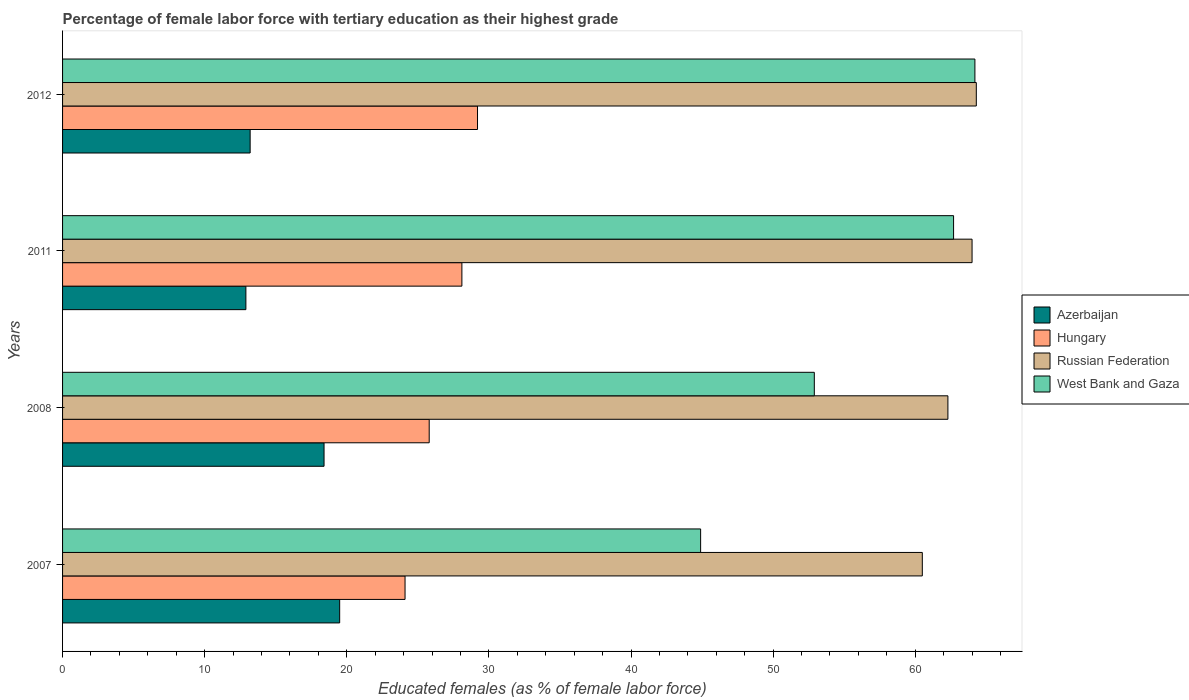Are the number of bars per tick equal to the number of legend labels?
Your response must be concise. Yes. Are the number of bars on each tick of the Y-axis equal?
Your response must be concise. Yes. What is the percentage of female labor force with tertiary education in West Bank and Gaza in 2012?
Keep it short and to the point. 64.2. Across all years, what is the maximum percentage of female labor force with tertiary education in Russian Federation?
Keep it short and to the point. 64.3. Across all years, what is the minimum percentage of female labor force with tertiary education in Hungary?
Give a very brief answer. 24.1. In which year was the percentage of female labor force with tertiary education in West Bank and Gaza minimum?
Ensure brevity in your answer.  2007. What is the total percentage of female labor force with tertiary education in West Bank and Gaza in the graph?
Your response must be concise. 224.7. What is the difference between the percentage of female labor force with tertiary education in Hungary in 2007 and that in 2008?
Offer a very short reply. -1.7. What is the difference between the percentage of female labor force with tertiary education in Hungary in 2007 and the percentage of female labor force with tertiary education in West Bank and Gaza in 2012?
Make the answer very short. -40.1. What is the average percentage of female labor force with tertiary education in West Bank and Gaza per year?
Give a very brief answer. 56.18. In the year 2011, what is the difference between the percentage of female labor force with tertiary education in Hungary and percentage of female labor force with tertiary education in Azerbaijan?
Your response must be concise. 15.2. What is the ratio of the percentage of female labor force with tertiary education in West Bank and Gaza in 2007 to that in 2012?
Provide a succinct answer. 0.7. What is the difference between the highest and the second highest percentage of female labor force with tertiary education in West Bank and Gaza?
Your answer should be very brief. 1.5. What is the difference between the highest and the lowest percentage of female labor force with tertiary education in Hungary?
Make the answer very short. 5.1. Is it the case that in every year, the sum of the percentage of female labor force with tertiary education in West Bank and Gaza and percentage of female labor force with tertiary education in Russian Federation is greater than the sum of percentage of female labor force with tertiary education in Azerbaijan and percentage of female labor force with tertiary education in Hungary?
Your answer should be compact. Yes. What does the 1st bar from the top in 2008 represents?
Your response must be concise. West Bank and Gaza. What does the 4th bar from the bottom in 2011 represents?
Offer a very short reply. West Bank and Gaza. Are all the bars in the graph horizontal?
Your answer should be very brief. Yes. Are the values on the major ticks of X-axis written in scientific E-notation?
Provide a succinct answer. No. Does the graph contain any zero values?
Offer a terse response. No. Where does the legend appear in the graph?
Your answer should be compact. Center right. What is the title of the graph?
Your response must be concise. Percentage of female labor force with tertiary education as their highest grade. What is the label or title of the X-axis?
Offer a terse response. Educated females (as % of female labor force). What is the Educated females (as % of female labor force) in Hungary in 2007?
Your response must be concise. 24.1. What is the Educated females (as % of female labor force) in Russian Federation in 2007?
Provide a short and direct response. 60.5. What is the Educated females (as % of female labor force) of West Bank and Gaza in 2007?
Offer a very short reply. 44.9. What is the Educated females (as % of female labor force) in Azerbaijan in 2008?
Offer a terse response. 18.4. What is the Educated females (as % of female labor force) in Hungary in 2008?
Your answer should be compact. 25.8. What is the Educated females (as % of female labor force) in Russian Federation in 2008?
Make the answer very short. 62.3. What is the Educated females (as % of female labor force) of West Bank and Gaza in 2008?
Provide a succinct answer. 52.9. What is the Educated females (as % of female labor force) of Azerbaijan in 2011?
Offer a terse response. 12.9. What is the Educated females (as % of female labor force) in Hungary in 2011?
Offer a very short reply. 28.1. What is the Educated females (as % of female labor force) of West Bank and Gaza in 2011?
Your answer should be very brief. 62.7. What is the Educated females (as % of female labor force) of Azerbaijan in 2012?
Your response must be concise. 13.2. What is the Educated females (as % of female labor force) in Hungary in 2012?
Your response must be concise. 29.2. What is the Educated females (as % of female labor force) of Russian Federation in 2012?
Give a very brief answer. 64.3. What is the Educated females (as % of female labor force) of West Bank and Gaza in 2012?
Keep it short and to the point. 64.2. Across all years, what is the maximum Educated females (as % of female labor force) in Azerbaijan?
Your response must be concise. 19.5. Across all years, what is the maximum Educated females (as % of female labor force) of Hungary?
Your answer should be very brief. 29.2. Across all years, what is the maximum Educated females (as % of female labor force) of Russian Federation?
Offer a very short reply. 64.3. Across all years, what is the maximum Educated females (as % of female labor force) in West Bank and Gaza?
Provide a short and direct response. 64.2. Across all years, what is the minimum Educated females (as % of female labor force) in Azerbaijan?
Ensure brevity in your answer.  12.9. Across all years, what is the minimum Educated females (as % of female labor force) in Hungary?
Your answer should be compact. 24.1. Across all years, what is the minimum Educated females (as % of female labor force) of Russian Federation?
Offer a terse response. 60.5. Across all years, what is the minimum Educated females (as % of female labor force) in West Bank and Gaza?
Offer a very short reply. 44.9. What is the total Educated females (as % of female labor force) of Azerbaijan in the graph?
Your response must be concise. 64. What is the total Educated females (as % of female labor force) of Hungary in the graph?
Your answer should be very brief. 107.2. What is the total Educated females (as % of female labor force) of Russian Federation in the graph?
Your answer should be compact. 251.1. What is the total Educated females (as % of female labor force) in West Bank and Gaza in the graph?
Your response must be concise. 224.7. What is the difference between the Educated females (as % of female labor force) in Hungary in 2007 and that in 2011?
Make the answer very short. -4. What is the difference between the Educated females (as % of female labor force) of West Bank and Gaza in 2007 and that in 2011?
Make the answer very short. -17.8. What is the difference between the Educated females (as % of female labor force) of Azerbaijan in 2007 and that in 2012?
Offer a very short reply. 6.3. What is the difference between the Educated females (as % of female labor force) of Hungary in 2007 and that in 2012?
Offer a very short reply. -5.1. What is the difference between the Educated females (as % of female labor force) in Russian Federation in 2007 and that in 2012?
Make the answer very short. -3.8. What is the difference between the Educated females (as % of female labor force) in West Bank and Gaza in 2007 and that in 2012?
Make the answer very short. -19.3. What is the difference between the Educated females (as % of female labor force) of Azerbaijan in 2008 and that in 2011?
Provide a short and direct response. 5.5. What is the difference between the Educated females (as % of female labor force) of Russian Federation in 2008 and that in 2011?
Make the answer very short. -1.7. What is the difference between the Educated females (as % of female labor force) of Azerbaijan in 2007 and the Educated females (as % of female labor force) of Russian Federation in 2008?
Offer a very short reply. -42.8. What is the difference between the Educated females (as % of female labor force) of Azerbaijan in 2007 and the Educated females (as % of female labor force) of West Bank and Gaza in 2008?
Ensure brevity in your answer.  -33.4. What is the difference between the Educated females (as % of female labor force) in Hungary in 2007 and the Educated females (as % of female labor force) in Russian Federation in 2008?
Make the answer very short. -38.2. What is the difference between the Educated females (as % of female labor force) in Hungary in 2007 and the Educated females (as % of female labor force) in West Bank and Gaza in 2008?
Offer a very short reply. -28.8. What is the difference between the Educated females (as % of female labor force) in Russian Federation in 2007 and the Educated females (as % of female labor force) in West Bank and Gaza in 2008?
Offer a terse response. 7.6. What is the difference between the Educated females (as % of female labor force) in Azerbaijan in 2007 and the Educated females (as % of female labor force) in Russian Federation in 2011?
Provide a short and direct response. -44.5. What is the difference between the Educated females (as % of female labor force) in Azerbaijan in 2007 and the Educated females (as % of female labor force) in West Bank and Gaza in 2011?
Provide a succinct answer. -43.2. What is the difference between the Educated females (as % of female labor force) of Hungary in 2007 and the Educated females (as % of female labor force) of Russian Federation in 2011?
Keep it short and to the point. -39.9. What is the difference between the Educated females (as % of female labor force) of Hungary in 2007 and the Educated females (as % of female labor force) of West Bank and Gaza in 2011?
Your answer should be compact. -38.6. What is the difference between the Educated females (as % of female labor force) of Azerbaijan in 2007 and the Educated females (as % of female labor force) of Hungary in 2012?
Ensure brevity in your answer.  -9.7. What is the difference between the Educated females (as % of female labor force) in Azerbaijan in 2007 and the Educated females (as % of female labor force) in Russian Federation in 2012?
Provide a succinct answer. -44.8. What is the difference between the Educated females (as % of female labor force) in Azerbaijan in 2007 and the Educated females (as % of female labor force) in West Bank and Gaza in 2012?
Provide a short and direct response. -44.7. What is the difference between the Educated females (as % of female labor force) in Hungary in 2007 and the Educated females (as % of female labor force) in Russian Federation in 2012?
Ensure brevity in your answer.  -40.2. What is the difference between the Educated females (as % of female labor force) of Hungary in 2007 and the Educated females (as % of female labor force) of West Bank and Gaza in 2012?
Offer a very short reply. -40.1. What is the difference between the Educated females (as % of female labor force) in Azerbaijan in 2008 and the Educated females (as % of female labor force) in Russian Federation in 2011?
Make the answer very short. -45.6. What is the difference between the Educated females (as % of female labor force) in Azerbaijan in 2008 and the Educated females (as % of female labor force) in West Bank and Gaza in 2011?
Offer a terse response. -44.3. What is the difference between the Educated females (as % of female labor force) in Hungary in 2008 and the Educated females (as % of female labor force) in Russian Federation in 2011?
Your answer should be very brief. -38.2. What is the difference between the Educated females (as % of female labor force) in Hungary in 2008 and the Educated females (as % of female labor force) in West Bank and Gaza in 2011?
Keep it short and to the point. -36.9. What is the difference between the Educated females (as % of female labor force) of Azerbaijan in 2008 and the Educated females (as % of female labor force) of Hungary in 2012?
Provide a short and direct response. -10.8. What is the difference between the Educated females (as % of female labor force) of Azerbaijan in 2008 and the Educated females (as % of female labor force) of Russian Federation in 2012?
Provide a short and direct response. -45.9. What is the difference between the Educated females (as % of female labor force) in Azerbaijan in 2008 and the Educated females (as % of female labor force) in West Bank and Gaza in 2012?
Offer a terse response. -45.8. What is the difference between the Educated females (as % of female labor force) of Hungary in 2008 and the Educated females (as % of female labor force) of Russian Federation in 2012?
Offer a very short reply. -38.5. What is the difference between the Educated females (as % of female labor force) in Hungary in 2008 and the Educated females (as % of female labor force) in West Bank and Gaza in 2012?
Make the answer very short. -38.4. What is the difference between the Educated females (as % of female labor force) of Russian Federation in 2008 and the Educated females (as % of female labor force) of West Bank and Gaza in 2012?
Your answer should be very brief. -1.9. What is the difference between the Educated females (as % of female labor force) in Azerbaijan in 2011 and the Educated females (as % of female labor force) in Hungary in 2012?
Your response must be concise. -16.3. What is the difference between the Educated females (as % of female labor force) of Azerbaijan in 2011 and the Educated females (as % of female labor force) of Russian Federation in 2012?
Keep it short and to the point. -51.4. What is the difference between the Educated females (as % of female labor force) in Azerbaijan in 2011 and the Educated females (as % of female labor force) in West Bank and Gaza in 2012?
Offer a terse response. -51.3. What is the difference between the Educated females (as % of female labor force) in Hungary in 2011 and the Educated females (as % of female labor force) in Russian Federation in 2012?
Give a very brief answer. -36.2. What is the difference between the Educated females (as % of female labor force) of Hungary in 2011 and the Educated females (as % of female labor force) of West Bank and Gaza in 2012?
Provide a succinct answer. -36.1. What is the average Educated females (as % of female labor force) of Azerbaijan per year?
Give a very brief answer. 16. What is the average Educated females (as % of female labor force) of Hungary per year?
Keep it short and to the point. 26.8. What is the average Educated females (as % of female labor force) of Russian Federation per year?
Provide a short and direct response. 62.77. What is the average Educated females (as % of female labor force) in West Bank and Gaza per year?
Give a very brief answer. 56.17. In the year 2007, what is the difference between the Educated females (as % of female labor force) of Azerbaijan and Educated females (as % of female labor force) of Hungary?
Provide a short and direct response. -4.6. In the year 2007, what is the difference between the Educated females (as % of female labor force) of Azerbaijan and Educated females (as % of female labor force) of Russian Federation?
Provide a succinct answer. -41. In the year 2007, what is the difference between the Educated females (as % of female labor force) of Azerbaijan and Educated females (as % of female labor force) of West Bank and Gaza?
Offer a very short reply. -25.4. In the year 2007, what is the difference between the Educated females (as % of female labor force) of Hungary and Educated females (as % of female labor force) of Russian Federation?
Your response must be concise. -36.4. In the year 2007, what is the difference between the Educated females (as % of female labor force) in Hungary and Educated females (as % of female labor force) in West Bank and Gaza?
Offer a very short reply. -20.8. In the year 2008, what is the difference between the Educated females (as % of female labor force) of Azerbaijan and Educated females (as % of female labor force) of Hungary?
Provide a short and direct response. -7.4. In the year 2008, what is the difference between the Educated females (as % of female labor force) of Azerbaijan and Educated females (as % of female labor force) of Russian Federation?
Give a very brief answer. -43.9. In the year 2008, what is the difference between the Educated females (as % of female labor force) in Azerbaijan and Educated females (as % of female labor force) in West Bank and Gaza?
Offer a very short reply. -34.5. In the year 2008, what is the difference between the Educated females (as % of female labor force) in Hungary and Educated females (as % of female labor force) in Russian Federation?
Your answer should be very brief. -36.5. In the year 2008, what is the difference between the Educated females (as % of female labor force) in Hungary and Educated females (as % of female labor force) in West Bank and Gaza?
Your response must be concise. -27.1. In the year 2008, what is the difference between the Educated females (as % of female labor force) in Russian Federation and Educated females (as % of female labor force) in West Bank and Gaza?
Your answer should be compact. 9.4. In the year 2011, what is the difference between the Educated females (as % of female labor force) of Azerbaijan and Educated females (as % of female labor force) of Hungary?
Offer a terse response. -15.2. In the year 2011, what is the difference between the Educated females (as % of female labor force) of Azerbaijan and Educated females (as % of female labor force) of Russian Federation?
Give a very brief answer. -51.1. In the year 2011, what is the difference between the Educated females (as % of female labor force) in Azerbaijan and Educated females (as % of female labor force) in West Bank and Gaza?
Give a very brief answer. -49.8. In the year 2011, what is the difference between the Educated females (as % of female labor force) in Hungary and Educated females (as % of female labor force) in Russian Federation?
Provide a succinct answer. -35.9. In the year 2011, what is the difference between the Educated females (as % of female labor force) of Hungary and Educated females (as % of female labor force) of West Bank and Gaza?
Offer a terse response. -34.6. In the year 2011, what is the difference between the Educated females (as % of female labor force) in Russian Federation and Educated females (as % of female labor force) in West Bank and Gaza?
Provide a succinct answer. 1.3. In the year 2012, what is the difference between the Educated females (as % of female labor force) of Azerbaijan and Educated females (as % of female labor force) of Russian Federation?
Ensure brevity in your answer.  -51.1. In the year 2012, what is the difference between the Educated females (as % of female labor force) of Azerbaijan and Educated females (as % of female labor force) of West Bank and Gaza?
Provide a short and direct response. -51. In the year 2012, what is the difference between the Educated females (as % of female labor force) of Hungary and Educated females (as % of female labor force) of Russian Federation?
Provide a short and direct response. -35.1. In the year 2012, what is the difference between the Educated females (as % of female labor force) in Hungary and Educated females (as % of female labor force) in West Bank and Gaza?
Your answer should be compact. -35. What is the ratio of the Educated females (as % of female labor force) in Azerbaijan in 2007 to that in 2008?
Ensure brevity in your answer.  1.06. What is the ratio of the Educated females (as % of female labor force) of Hungary in 2007 to that in 2008?
Give a very brief answer. 0.93. What is the ratio of the Educated females (as % of female labor force) of Russian Federation in 2007 to that in 2008?
Give a very brief answer. 0.97. What is the ratio of the Educated females (as % of female labor force) in West Bank and Gaza in 2007 to that in 2008?
Provide a succinct answer. 0.85. What is the ratio of the Educated females (as % of female labor force) of Azerbaijan in 2007 to that in 2011?
Provide a succinct answer. 1.51. What is the ratio of the Educated females (as % of female labor force) in Hungary in 2007 to that in 2011?
Provide a succinct answer. 0.86. What is the ratio of the Educated females (as % of female labor force) in Russian Federation in 2007 to that in 2011?
Your response must be concise. 0.95. What is the ratio of the Educated females (as % of female labor force) in West Bank and Gaza in 2007 to that in 2011?
Provide a succinct answer. 0.72. What is the ratio of the Educated females (as % of female labor force) of Azerbaijan in 2007 to that in 2012?
Keep it short and to the point. 1.48. What is the ratio of the Educated females (as % of female labor force) in Hungary in 2007 to that in 2012?
Your answer should be very brief. 0.83. What is the ratio of the Educated females (as % of female labor force) in Russian Federation in 2007 to that in 2012?
Provide a succinct answer. 0.94. What is the ratio of the Educated females (as % of female labor force) of West Bank and Gaza in 2007 to that in 2012?
Your response must be concise. 0.7. What is the ratio of the Educated females (as % of female labor force) of Azerbaijan in 2008 to that in 2011?
Provide a succinct answer. 1.43. What is the ratio of the Educated females (as % of female labor force) of Hungary in 2008 to that in 2011?
Provide a short and direct response. 0.92. What is the ratio of the Educated females (as % of female labor force) in Russian Federation in 2008 to that in 2011?
Ensure brevity in your answer.  0.97. What is the ratio of the Educated females (as % of female labor force) of West Bank and Gaza in 2008 to that in 2011?
Offer a terse response. 0.84. What is the ratio of the Educated females (as % of female labor force) of Azerbaijan in 2008 to that in 2012?
Offer a terse response. 1.39. What is the ratio of the Educated females (as % of female labor force) of Hungary in 2008 to that in 2012?
Offer a terse response. 0.88. What is the ratio of the Educated females (as % of female labor force) of Russian Federation in 2008 to that in 2012?
Make the answer very short. 0.97. What is the ratio of the Educated females (as % of female labor force) of West Bank and Gaza in 2008 to that in 2012?
Ensure brevity in your answer.  0.82. What is the ratio of the Educated females (as % of female labor force) in Azerbaijan in 2011 to that in 2012?
Offer a terse response. 0.98. What is the ratio of the Educated females (as % of female labor force) of Hungary in 2011 to that in 2012?
Offer a very short reply. 0.96. What is the ratio of the Educated females (as % of female labor force) in West Bank and Gaza in 2011 to that in 2012?
Keep it short and to the point. 0.98. What is the difference between the highest and the second highest Educated females (as % of female labor force) in Azerbaijan?
Make the answer very short. 1.1. What is the difference between the highest and the second highest Educated females (as % of female labor force) of Hungary?
Your answer should be compact. 1.1. What is the difference between the highest and the lowest Educated females (as % of female labor force) in Hungary?
Keep it short and to the point. 5.1. What is the difference between the highest and the lowest Educated females (as % of female labor force) of Russian Federation?
Keep it short and to the point. 3.8. What is the difference between the highest and the lowest Educated females (as % of female labor force) of West Bank and Gaza?
Make the answer very short. 19.3. 